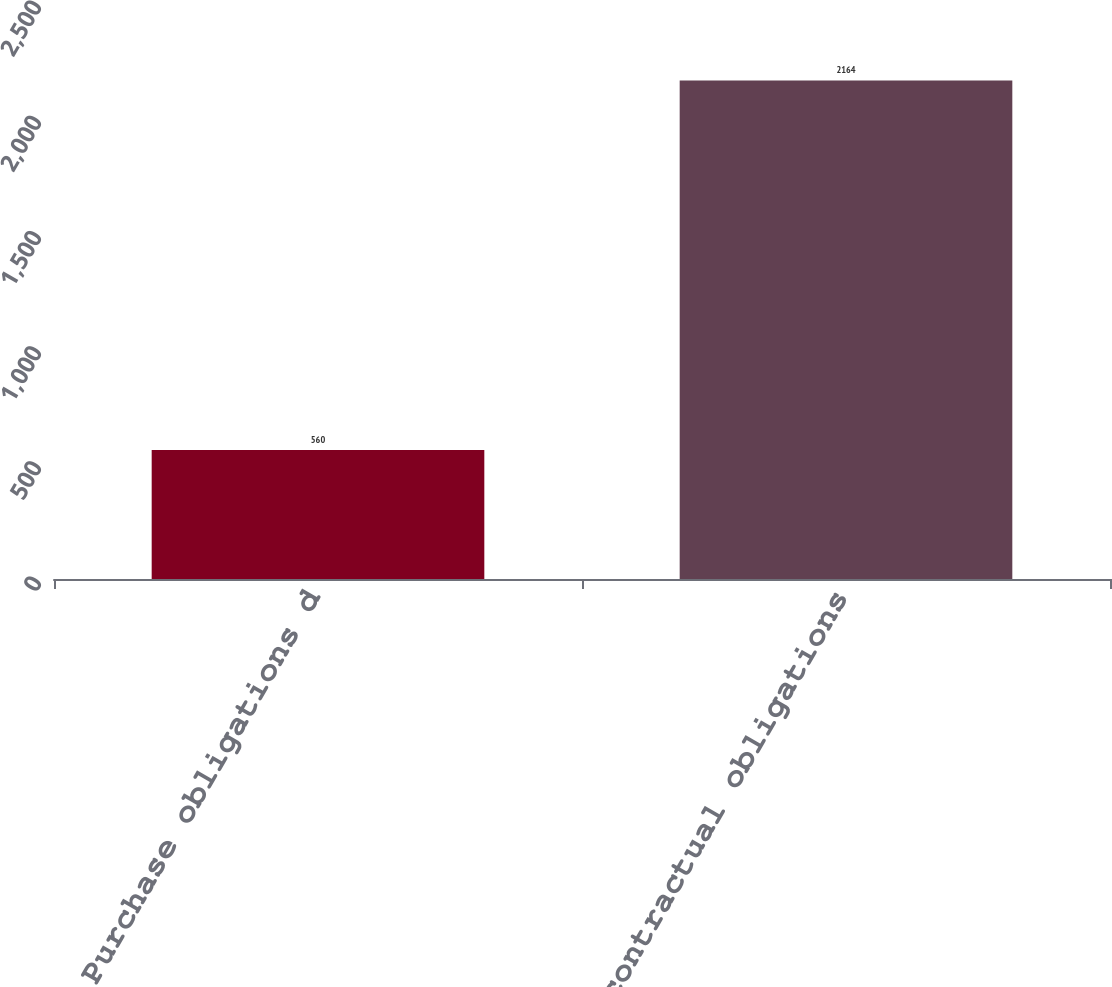<chart> <loc_0><loc_0><loc_500><loc_500><bar_chart><fcel>Purchase obligations d<fcel>Total contractual obligations<nl><fcel>560<fcel>2164<nl></chart> 